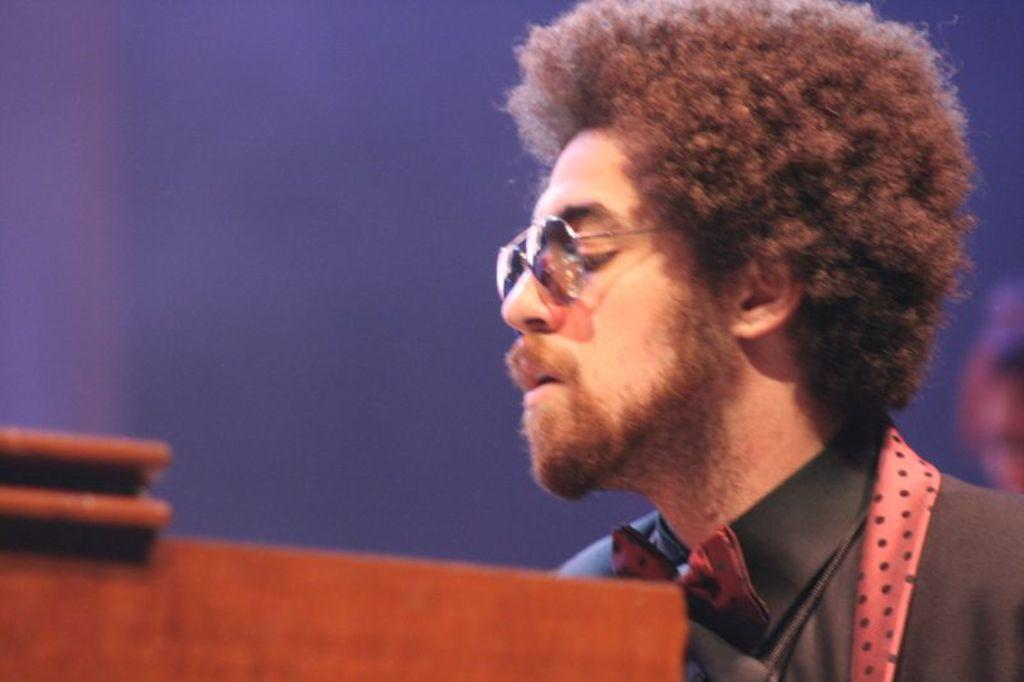Who is present in the image? There is a man in the image. What is the man wearing on his upper body? The man is wearing a black shirt and a red tie. What object is in front of the man? There is a table in front of the man. What color is the background of the image? The background of the image is blue. What type of quilt is being used to answer the man's questions in the image? There is no quilt present in the image, nor is there any indication that the man is asking or answering questions. 